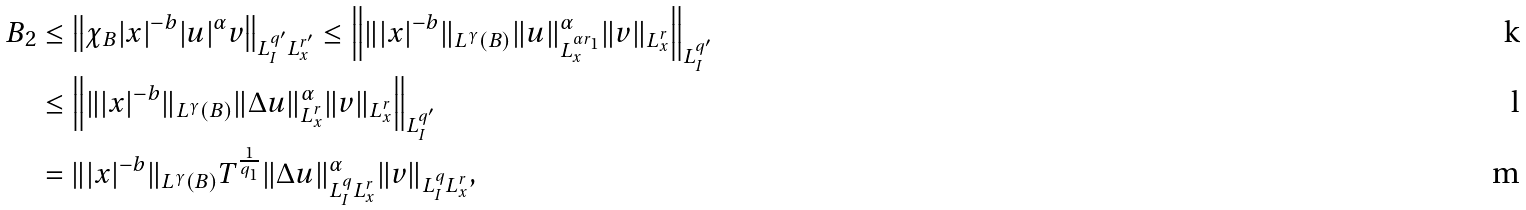Convert formula to latex. <formula><loc_0><loc_0><loc_500><loc_500>B _ { 2 } & \leq \left \| \chi _ { B } | x | ^ { - b } | u | ^ { \alpha } v \right \| _ { L ^ { q ^ { \prime } } _ { I } L _ { x } ^ { r ^ { \prime } } } \leq \left \| \| | x | ^ { - b } \| _ { L ^ { \gamma } ( B ) } \| u \| ^ { \alpha } _ { L _ { x } ^ { \alpha r _ { 1 } } } \| v \| _ { L ^ { r } _ { x } } \right \| _ { L ^ { q ^ { \prime } } _ { I } } \\ & \leq \left \| \| | x | ^ { - b } \| _ { L ^ { \gamma } ( B ) } \| \Delta u \| ^ { \alpha } _ { L _ { x } ^ { r } } \| v \| _ { L ^ { r } _ { x } } \right \| _ { L ^ { q ^ { \prime } } _ { I } } \\ & = \| | x | ^ { - b } \| _ { L ^ { \gamma } ( B ) } T ^ { \frac { 1 } { q _ { 1 } } } \| \Delta u \| ^ { \alpha } _ { L _ { I } ^ { q } L ^ { r } _ { x } } \| v \| _ { L ^ { q } _ { I } L _ { x } ^ { r } } ,</formula> 